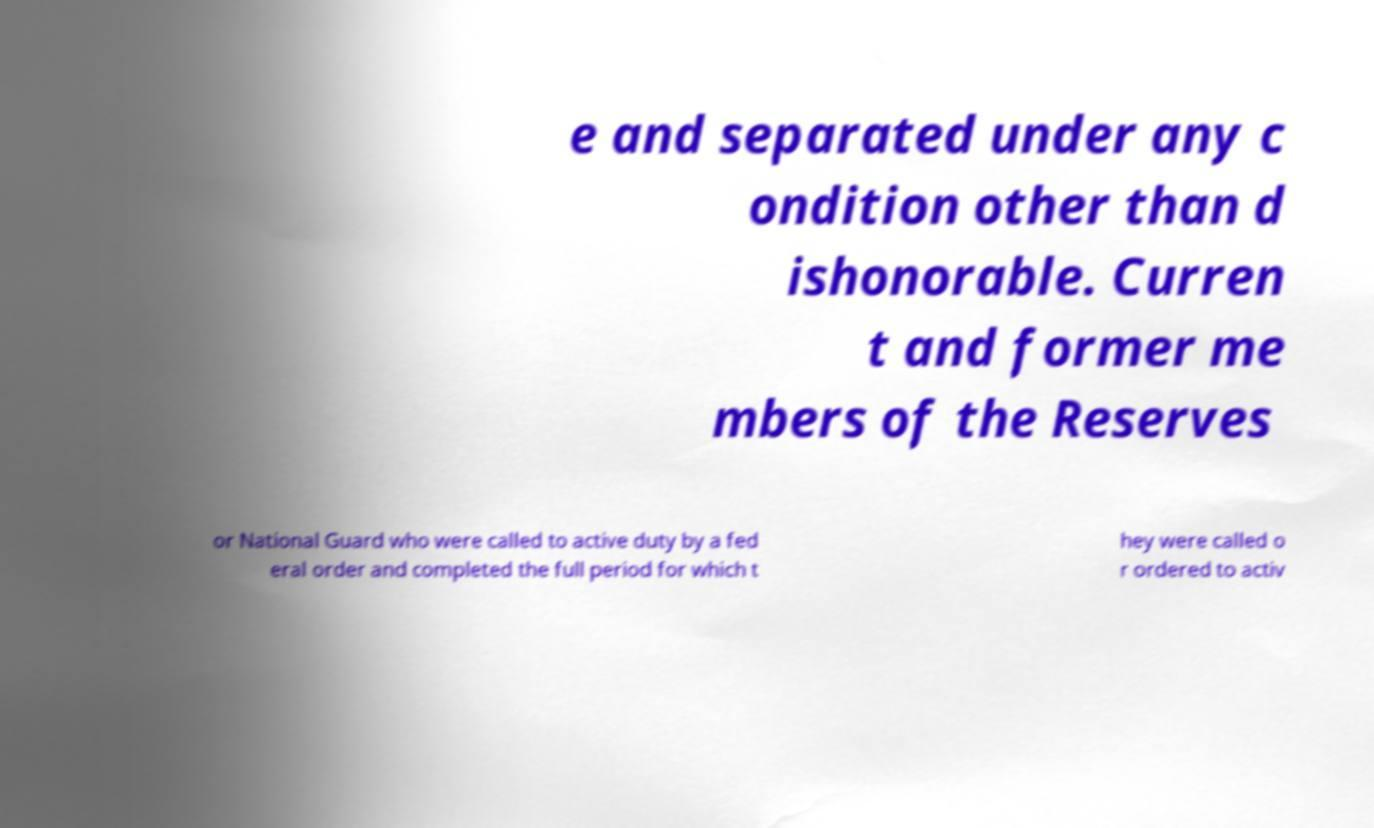For documentation purposes, I need the text within this image transcribed. Could you provide that? e and separated under any c ondition other than d ishonorable. Curren t and former me mbers of the Reserves or National Guard who were called to active duty by a fed eral order and completed the full period for which t hey were called o r ordered to activ 